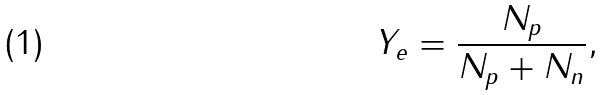<formula> <loc_0><loc_0><loc_500><loc_500>Y _ { e } = \frac { N _ { p } } { N _ { p } + N _ { n } } ,</formula> 